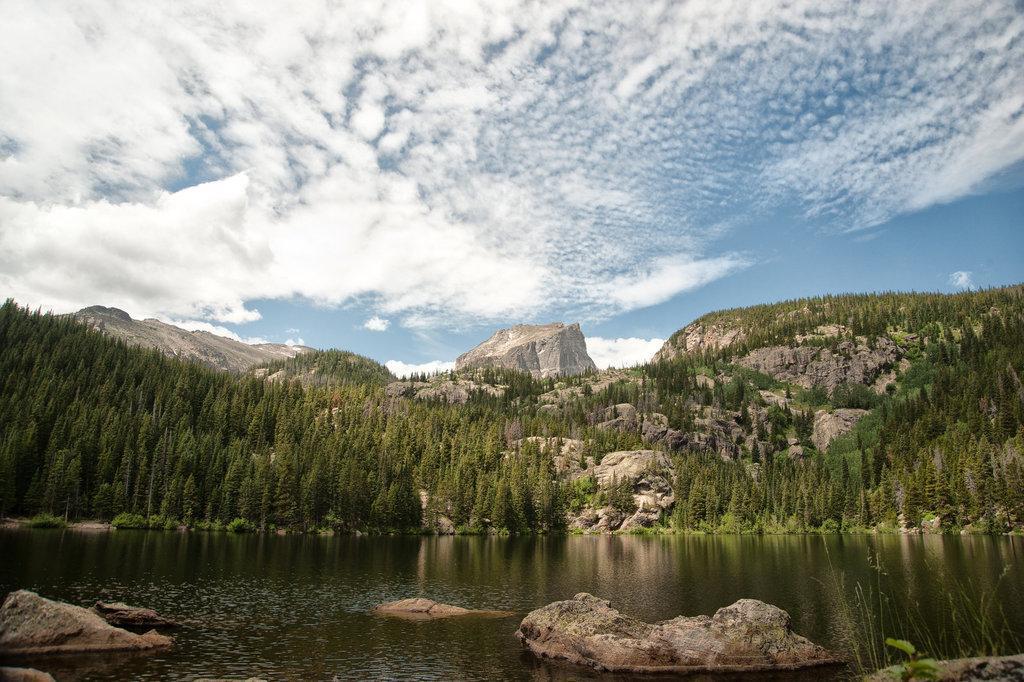How would you summarize this image in a sentence or two? In this picture I can see there is a lake, there are plants, rocks in the lake and in the backdrop there are mountains and the sky is clear. 